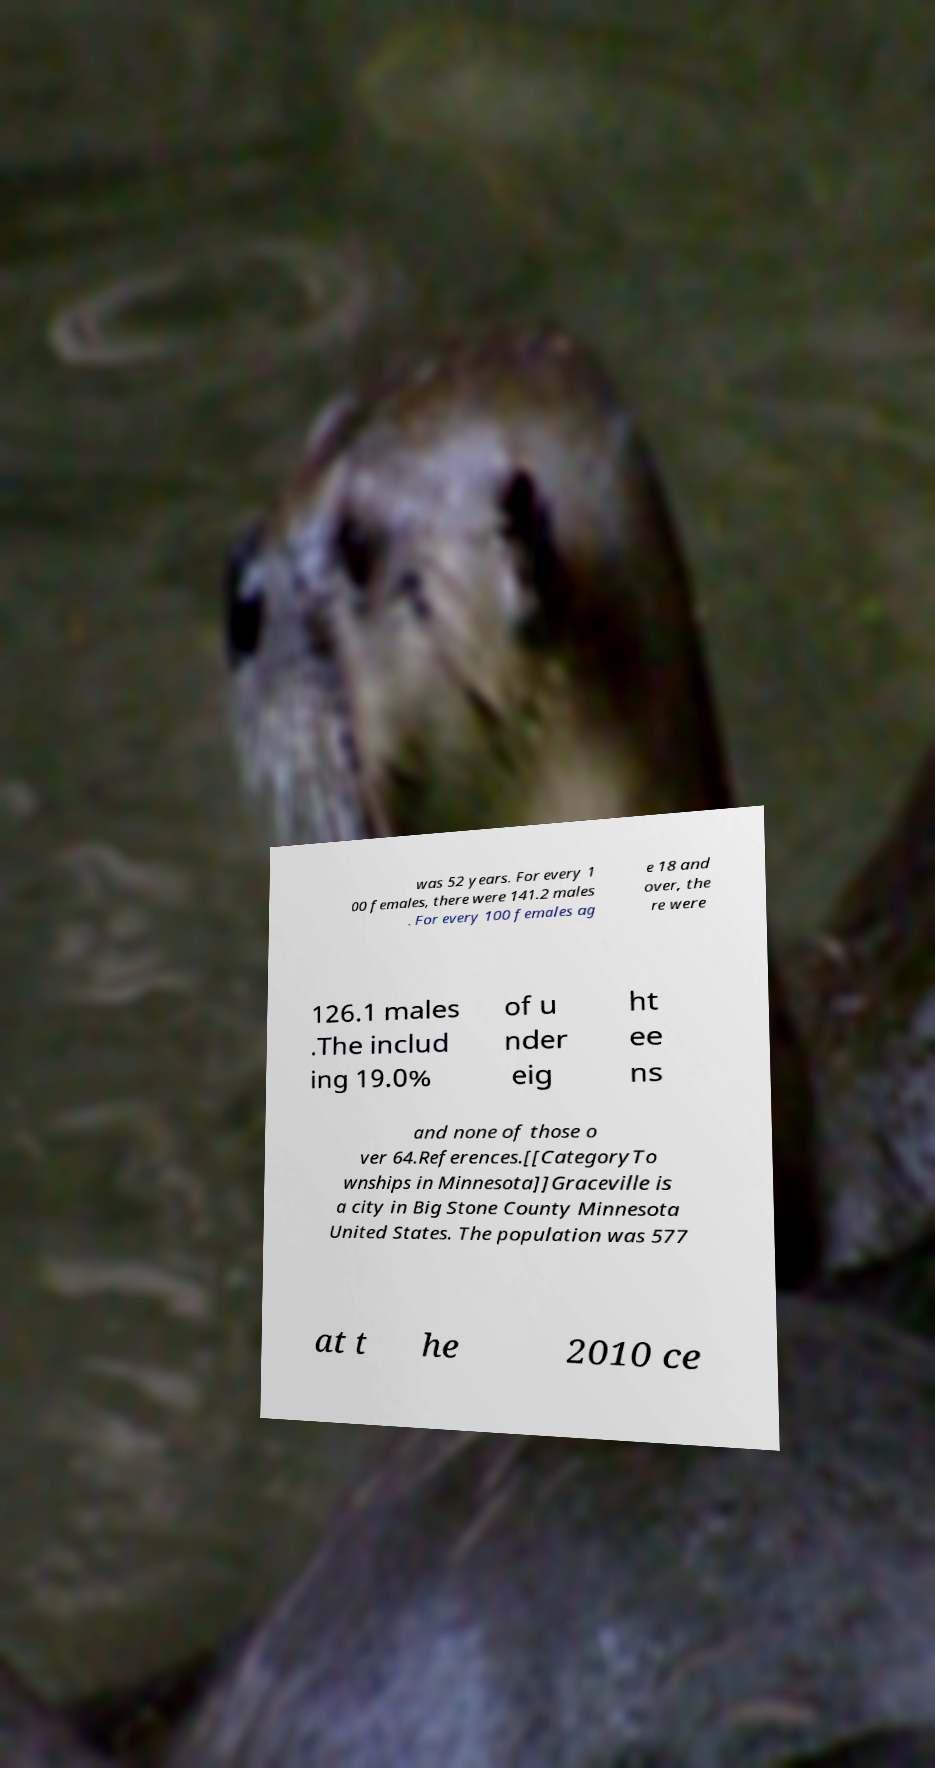Please identify and transcribe the text found in this image. was 52 years. For every 1 00 females, there were 141.2 males . For every 100 females ag e 18 and over, the re were 126.1 males .The includ ing 19.0% of u nder eig ht ee ns and none of those o ver 64.References.[[CategoryTo wnships in Minnesota]]Graceville is a city in Big Stone County Minnesota United States. The population was 577 at t he 2010 ce 